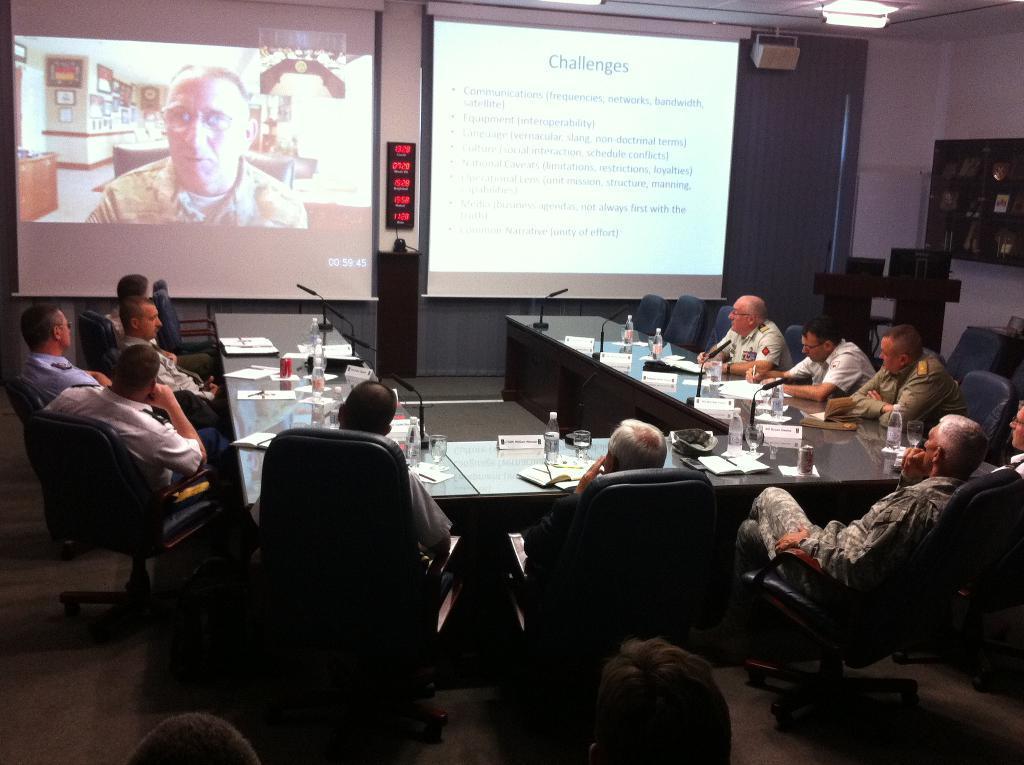Can you describe this image briefly? On the background we can see two screens. This is a wall. This is a cupboard. Here we can see few persons sitting on chairs in front of a table and on the table we can see mikes, water bottles, tins , glass of water. 